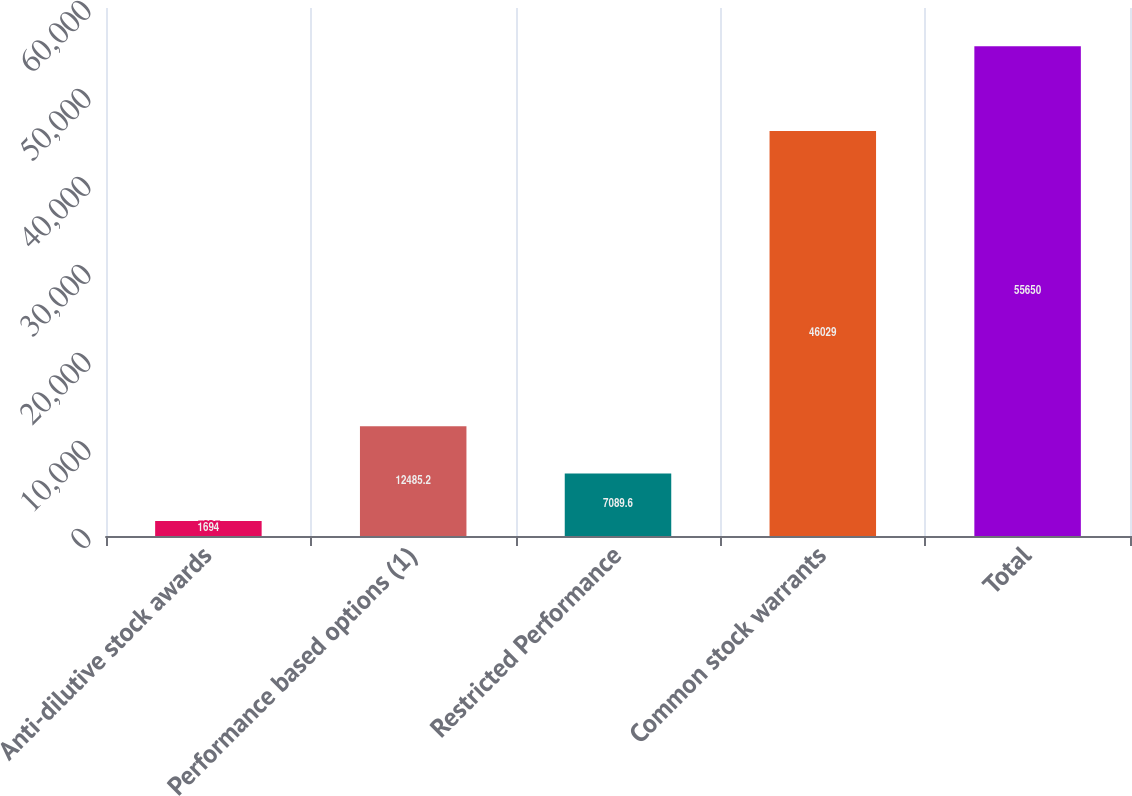Convert chart to OTSL. <chart><loc_0><loc_0><loc_500><loc_500><bar_chart><fcel>Anti-dilutive stock awards<fcel>Performance based options (1)<fcel>Restricted Performance<fcel>Common stock warrants<fcel>Total<nl><fcel>1694<fcel>12485.2<fcel>7089.6<fcel>46029<fcel>55650<nl></chart> 